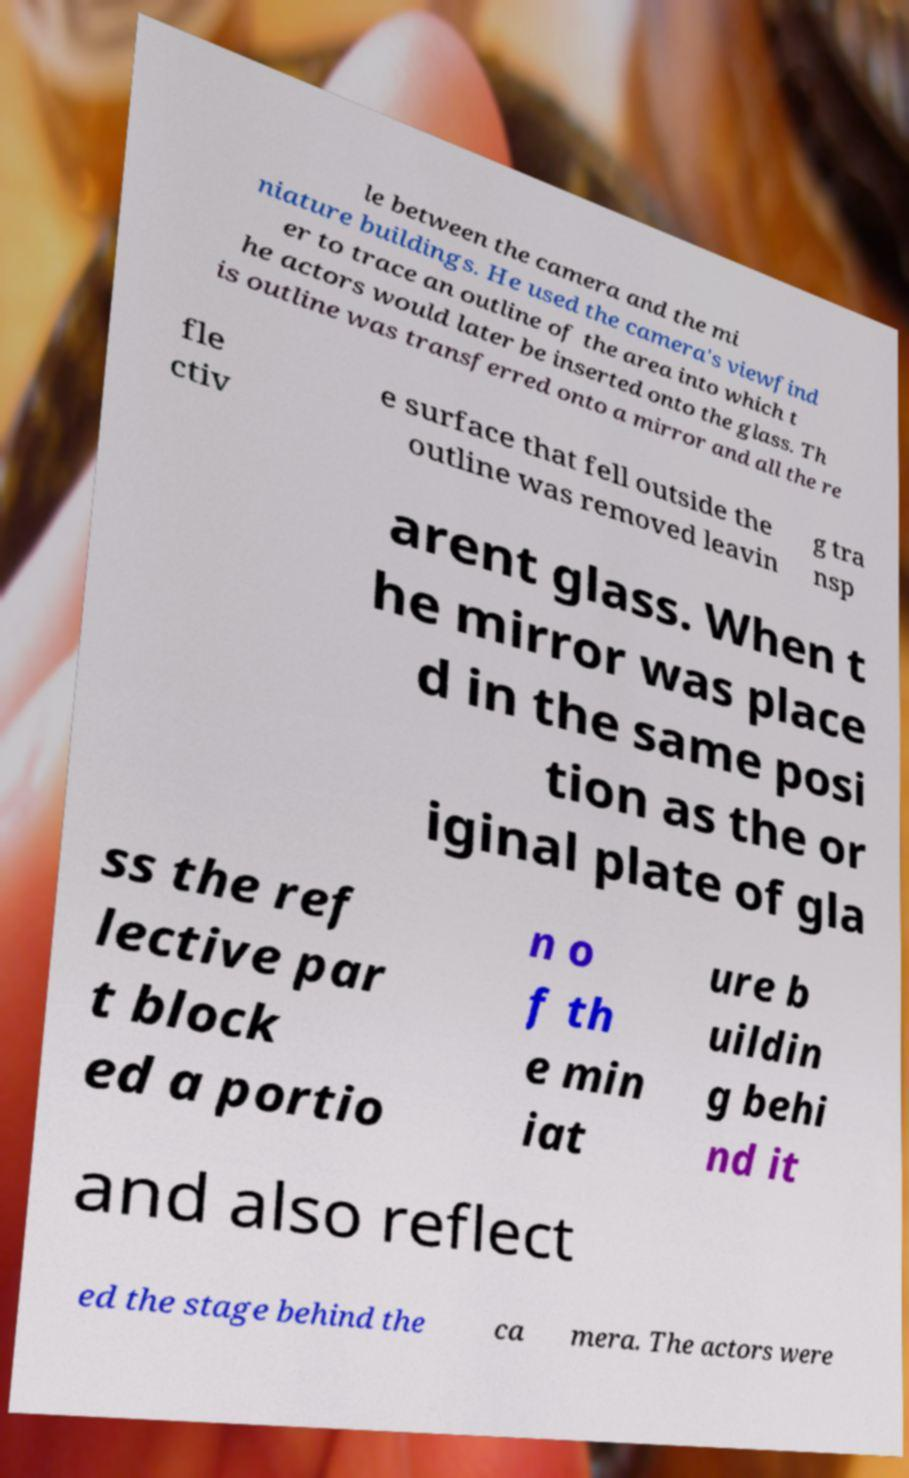Could you assist in decoding the text presented in this image and type it out clearly? le between the camera and the mi niature buildings. He used the camera's viewfind er to trace an outline of the area into which t he actors would later be inserted onto the glass. Th is outline was transferred onto a mirror and all the re fle ctiv e surface that fell outside the outline was removed leavin g tra nsp arent glass. When t he mirror was place d in the same posi tion as the or iginal plate of gla ss the ref lective par t block ed a portio n o f th e min iat ure b uildin g behi nd it and also reflect ed the stage behind the ca mera. The actors were 